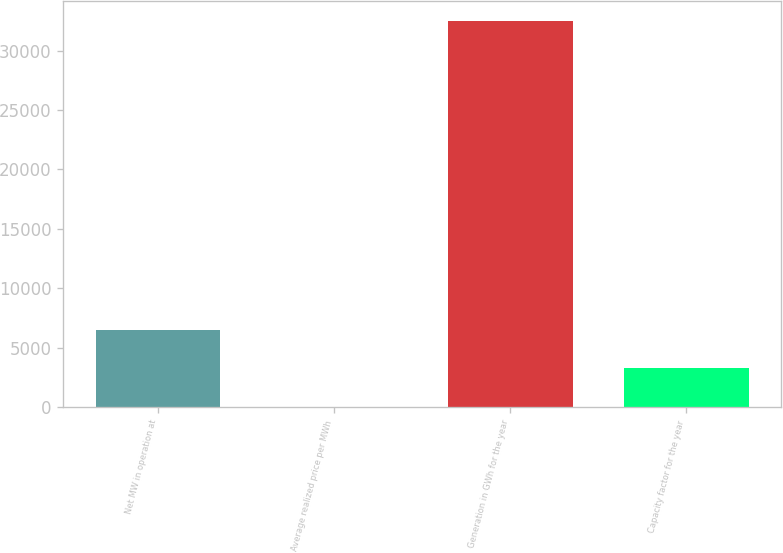Convert chart to OTSL. <chart><loc_0><loc_0><loc_500><loc_500><bar_chart><fcel>Net MW in operation at<fcel>Average realized price per MWh<fcel>Generation in GWh for the year<fcel>Capacity factor for the year<nl><fcel>6537.8<fcel>41.26<fcel>32524<fcel>3289.53<nl></chart> 